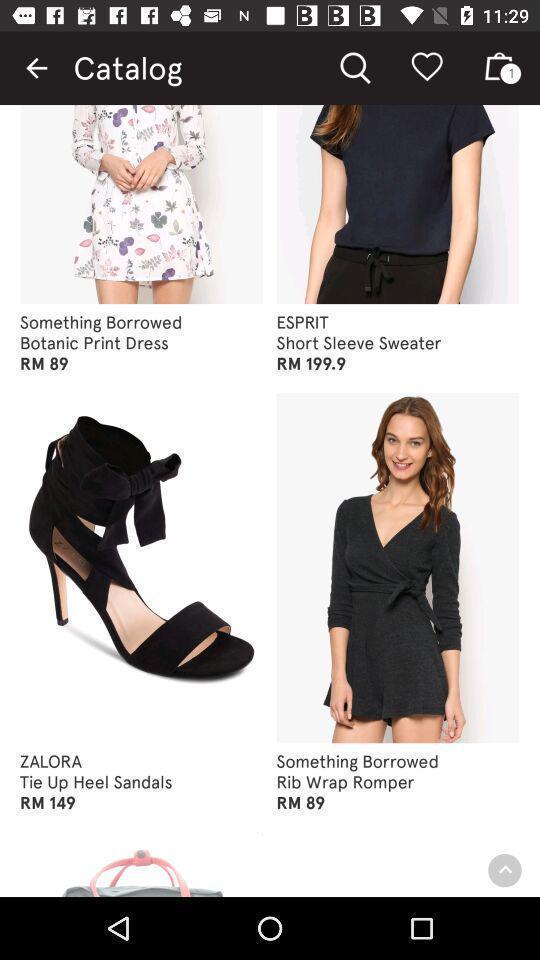Please provide a description for this image. Screen displaying multiple product images with price. 